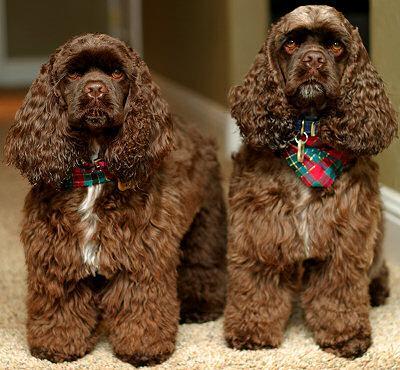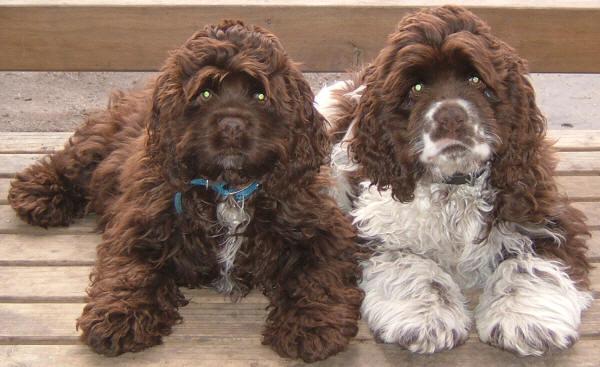The first image is the image on the left, the second image is the image on the right. Given the left and right images, does the statement "The left image features a very young chocolate-colored spaniel in a sitting position, and the right image features a bigger sitting spaniel." hold true? Answer yes or no. No. The first image is the image on the left, the second image is the image on the right. Evaluate the accuracy of this statement regarding the images: "One dog is outside in one of the images.". Is it true? Answer yes or no. No. 